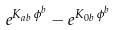Convert formula to latex. <formula><loc_0><loc_0><loc_500><loc_500>e ^ { K _ { a b } \, \phi ^ { b } } - e ^ { K _ { 0 b } \, \phi ^ { b } }</formula> 